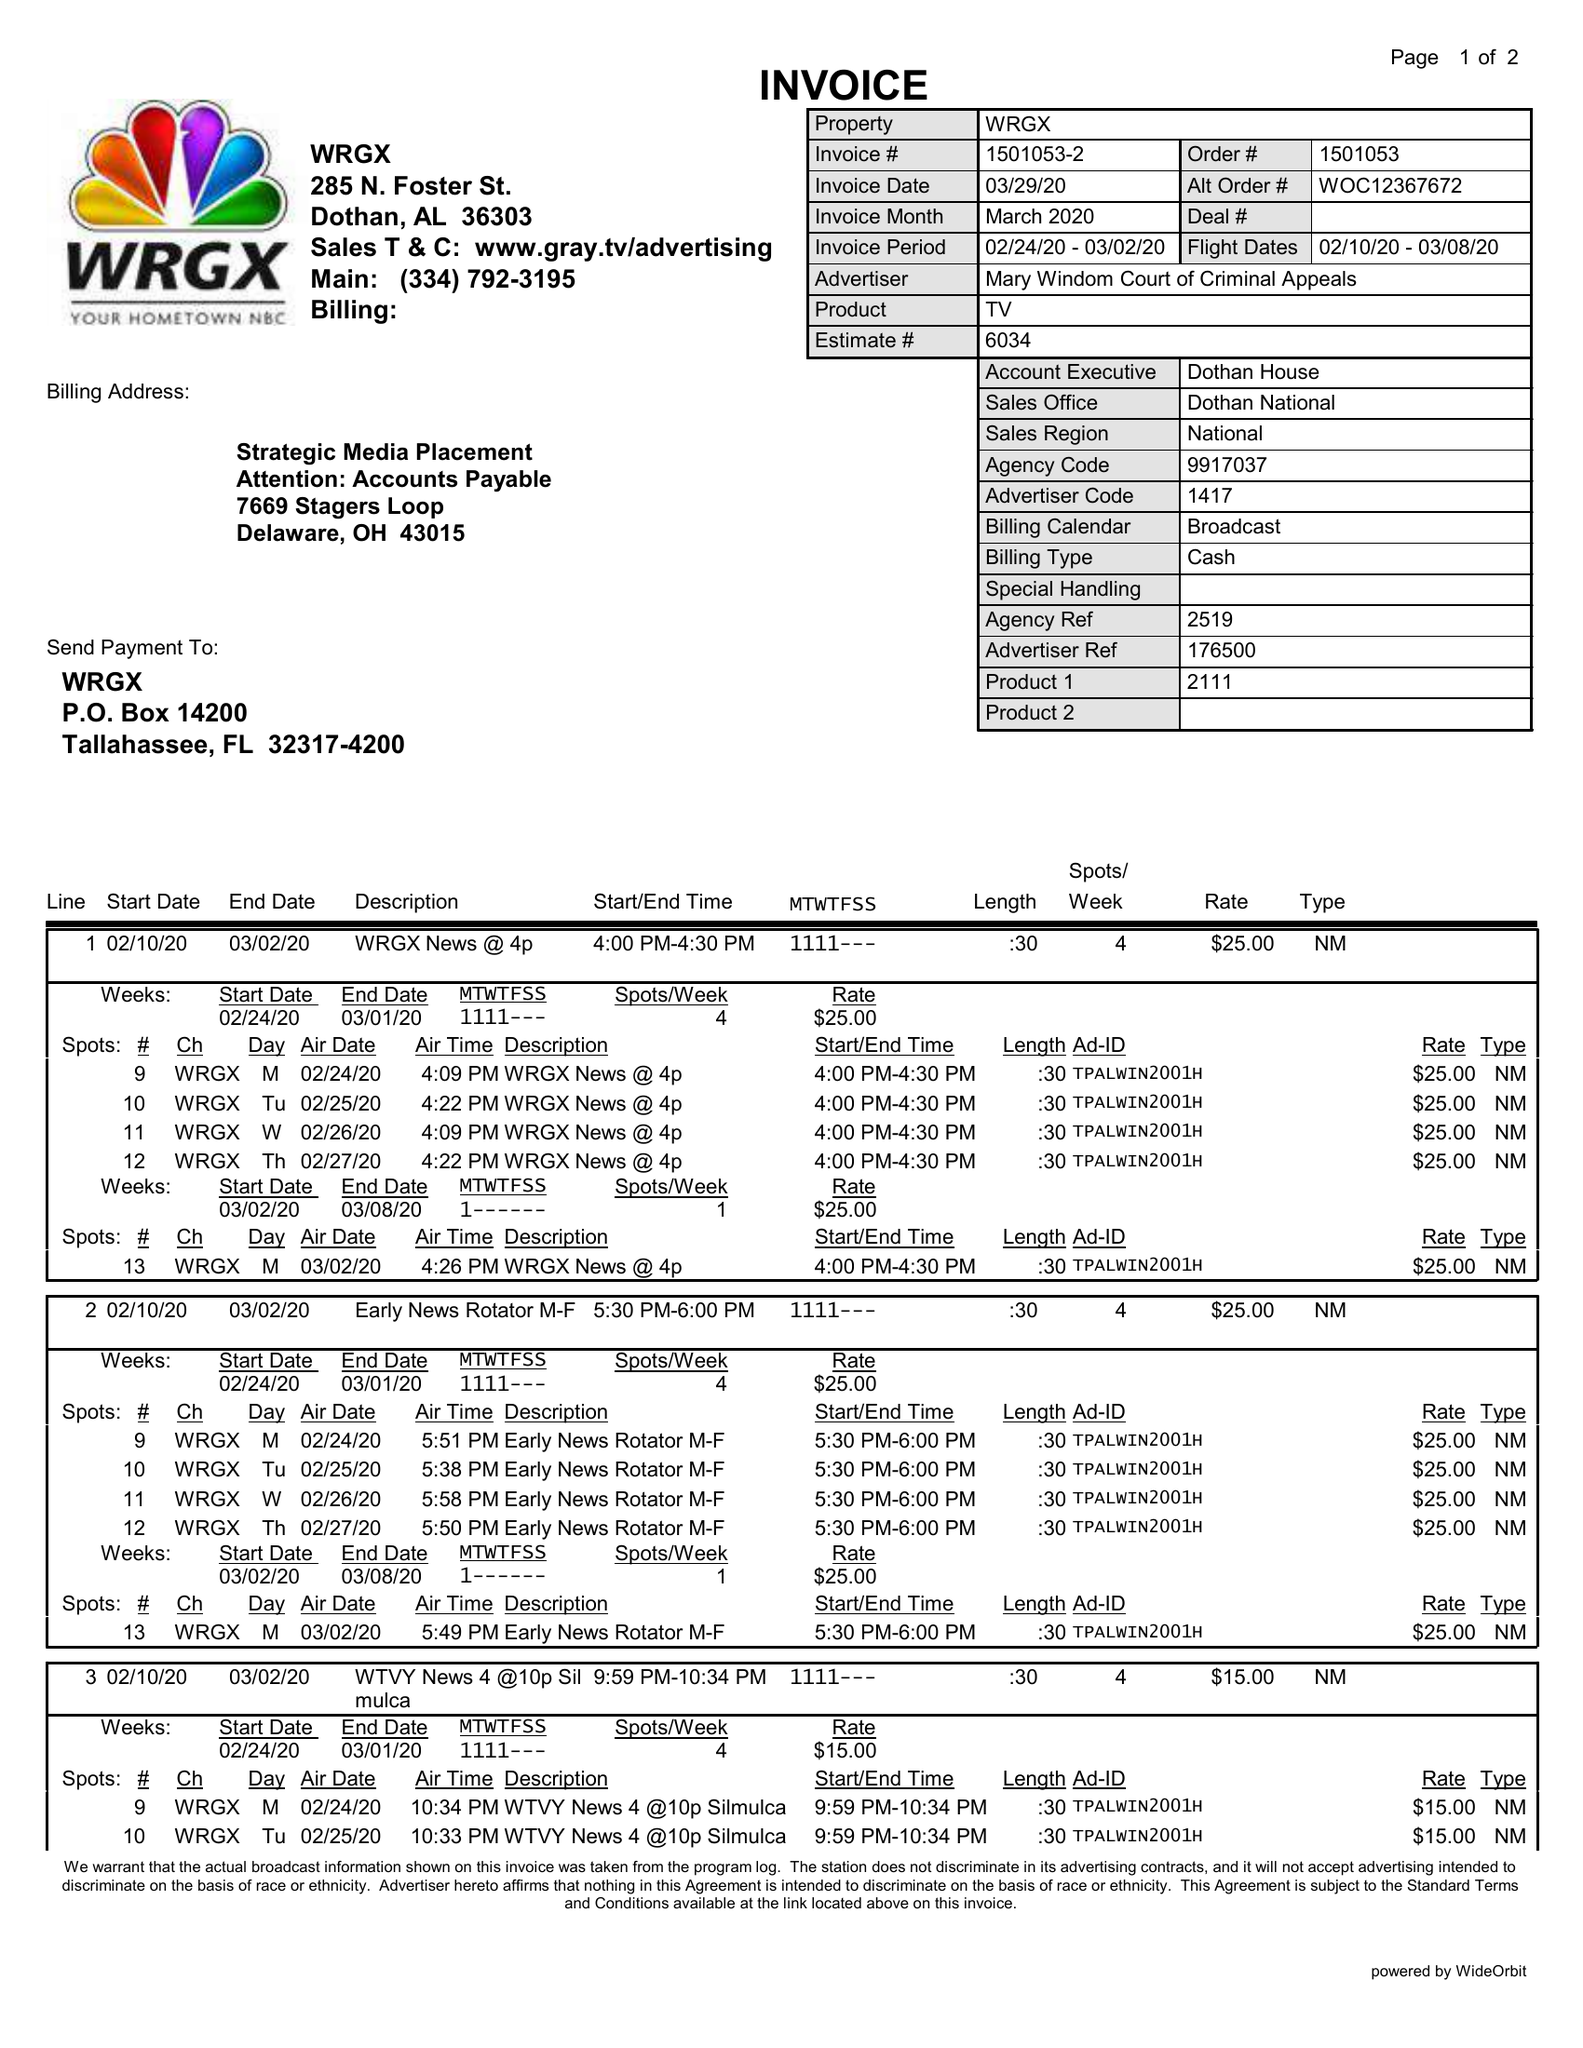What is the value for the contract_num?
Answer the question using a single word or phrase. 1501053 